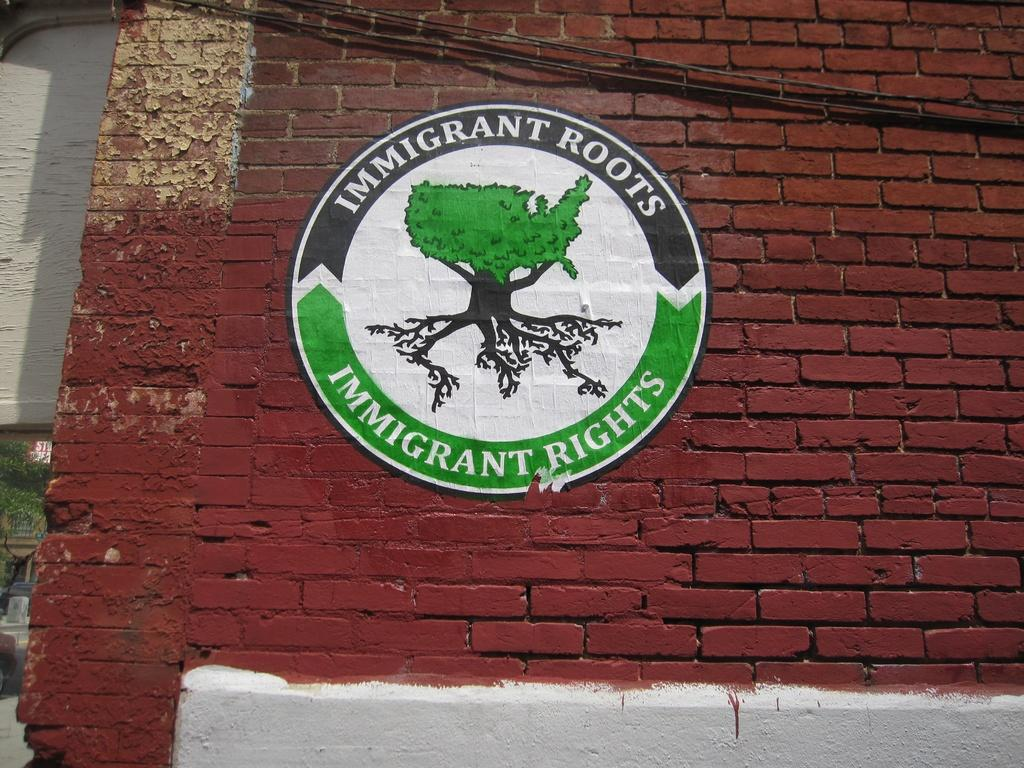What is featured in the image? There is a poster in the image. Where is the poster located? The poster is on a brick wall. Can you see a pig wearing a vest in the image? No, there is no pig or vest present in the image. 